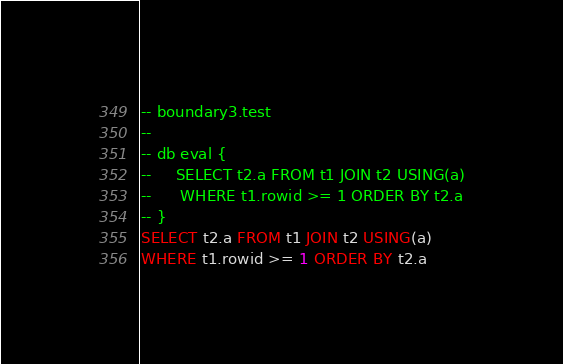Convert code to text. <code><loc_0><loc_0><loc_500><loc_500><_SQL_>-- boundary3.test
-- 
-- db eval {
--     SELECT t2.a FROM t1 JOIN t2 USING(a)
--      WHERE t1.rowid >= 1 ORDER BY t2.a
-- }
SELECT t2.a FROM t1 JOIN t2 USING(a)
WHERE t1.rowid >= 1 ORDER BY t2.a</code> 